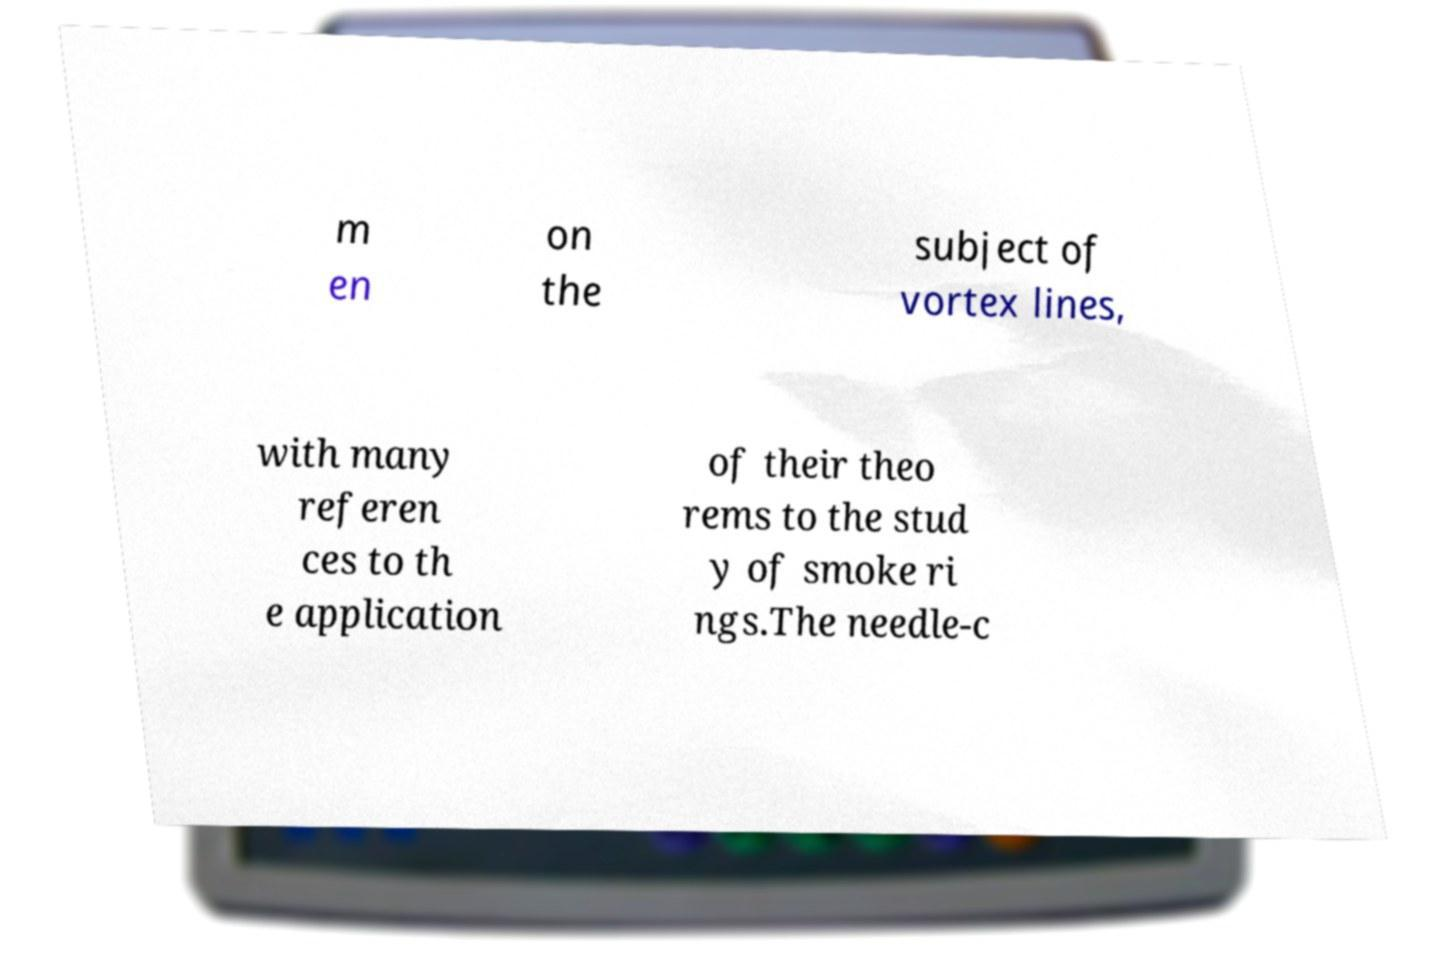Please read and relay the text visible in this image. What does it say? m en on the subject of vortex lines, with many referen ces to th e application of their theo rems to the stud y of smoke ri ngs.The needle-c 